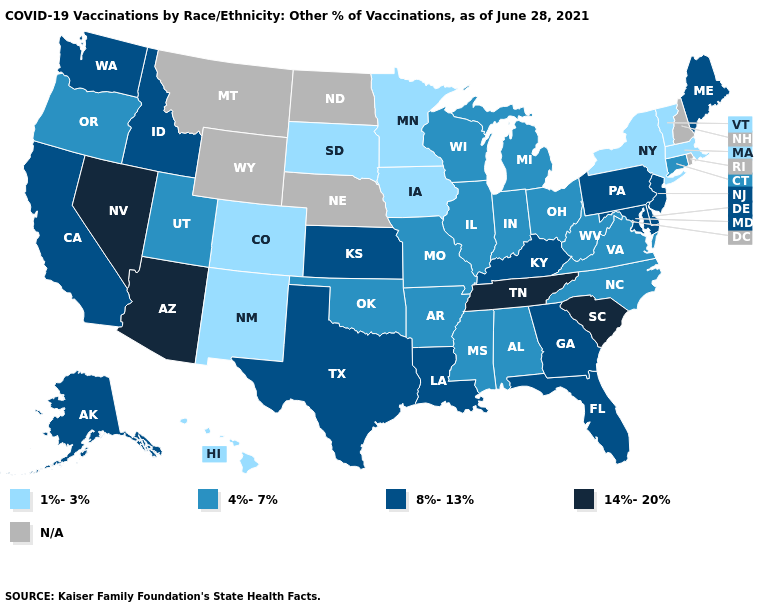Which states hav the highest value in the South?
Concise answer only. South Carolina, Tennessee. Which states have the highest value in the USA?
Give a very brief answer. Arizona, Nevada, South Carolina, Tennessee. What is the value of Louisiana?
Be succinct. 8%-13%. Name the states that have a value in the range N/A?
Short answer required. Montana, Nebraska, New Hampshire, North Dakota, Rhode Island, Wyoming. Name the states that have a value in the range 14%-20%?
Be succinct. Arizona, Nevada, South Carolina, Tennessee. Name the states that have a value in the range 8%-13%?
Concise answer only. Alaska, California, Delaware, Florida, Georgia, Idaho, Kansas, Kentucky, Louisiana, Maine, Maryland, New Jersey, Pennsylvania, Texas, Washington. What is the lowest value in the USA?
Give a very brief answer. 1%-3%. What is the value of New Jersey?
Short answer required. 8%-13%. What is the lowest value in states that border Indiana?
Answer briefly. 4%-7%. What is the lowest value in the USA?
Answer briefly. 1%-3%. Name the states that have a value in the range 4%-7%?
Be succinct. Alabama, Arkansas, Connecticut, Illinois, Indiana, Michigan, Mississippi, Missouri, North Carolina, Ohio, Oklahoma, Oregon, Utah, Virginia, West Virginia, Wisconsin. Name the states that have a value in the range 1%-3%?
Concise answer only. Colorado, Hawaii, Iowa, Massachusetts, Minnesota, New Mexico, New York, South Dakota, Vermont. Name the states that have a value in the range 4%-7%?
Give a very brief answer. Alabama, Arkansas, Connecticut, Illinois, Indiana, Michigan, Mississippi, Missouri, North Carolina, Ohio, Oklahoma, Oregon, Utah, Virginia, West Virginia, Wisconsin. How many symbols are there in the legend?
Quick response, please. 5. Does the first symbol in the legend represent the smallest category?
Be succinct. Yes. 